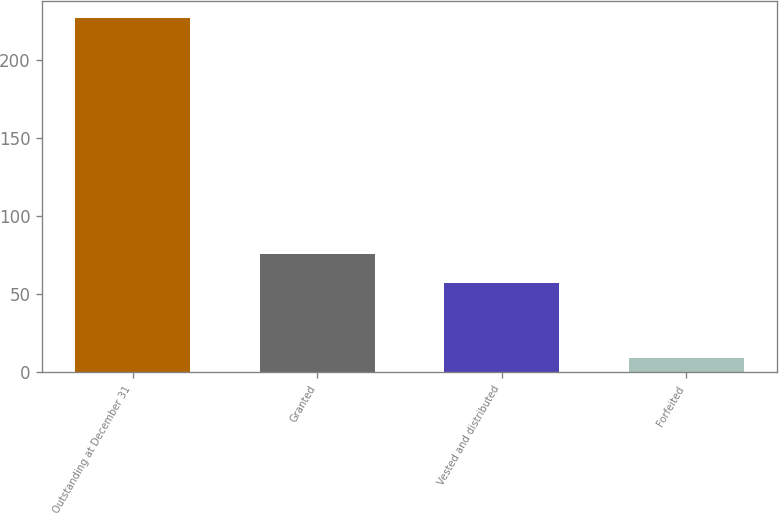Convert chart. <chart><loc_0><loc_0><loc_500><loc_500><bar_chart><fcel>Outstanding at December 31<fcel>Granted<fcel>Vested and distributed<fcel>Forfeited<nl><fcel>226.8<fcel>75.9<fcel>57<fcel>9<nl></chart> 